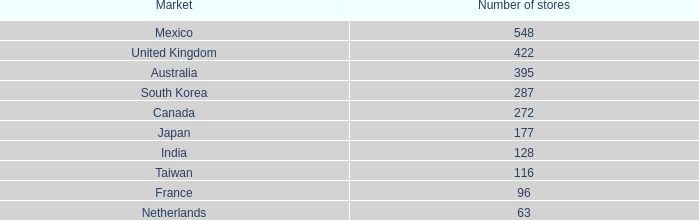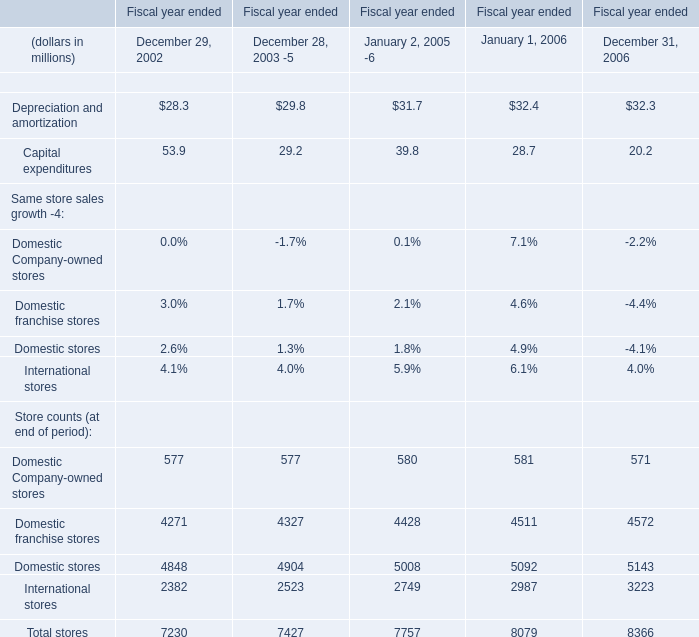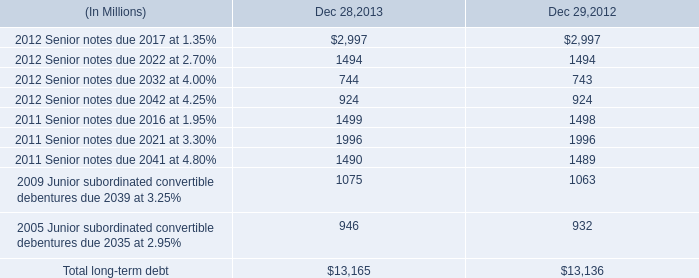What's the increasing rate of Domestic stores in 2016? (in %) 
Computations: ((5092 - 5008) / 5008)
Answer: 0.01677. 